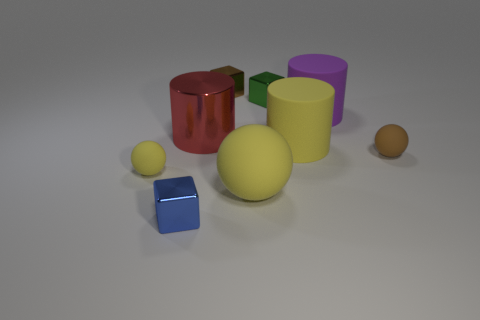What is the size of the cylinder that is the same color as the large sphere?
Offer a very short reply. Large. Is the green metal object the same size as the purple thing?
Your answer should be very brief. No. What is the color of the tiny thing that is both to the right of the blue cube and in front of the yellow cylinder?
Offer a terse response. Brown. What is the shape of the brown thing that is made of the same material as the purple cylinder?
Provide a succinct answer. Sphere. What number of things are both behind the small brown rubber ball and left of the big purple thing?
Offer a very short reply. 4. Are there any yellow matte balls to the left of the red cylinder?
Your answer should be very brief. Yes. Do the big yellow rubber object behind the tiny brown matte ball and the large matte thing behind the red object have the same shape?
Your answer should be compact. Yes. What number of objects are tiny red rubber spheres or brown objects that are behind the big purple cylinder?
Keep it short and to the point. 1. How many other things are there of the same shape as the small blue metal thing?
Your answer should be very brief. 2. Does the yellow ball that is right of the small yellow sphere have the same material as the small yellow sphere?
Give a very brief answer. Yes. 